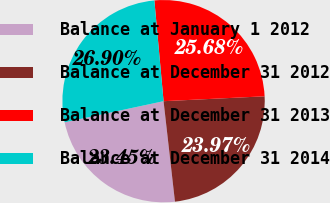Convert chart. <chart><loc_0><loc_0><loc_500><loc_500><pie_chart><fcel>Balance at January 1 2012<fcel>Balance at December 31 2012<fcel>Balance at December 31 2013<fcel>Balance at December 31 2014<nl><fcel>23.45%<fcel>23.97%<fcel>25.68%<fcel>26.9%<nl></chart> 